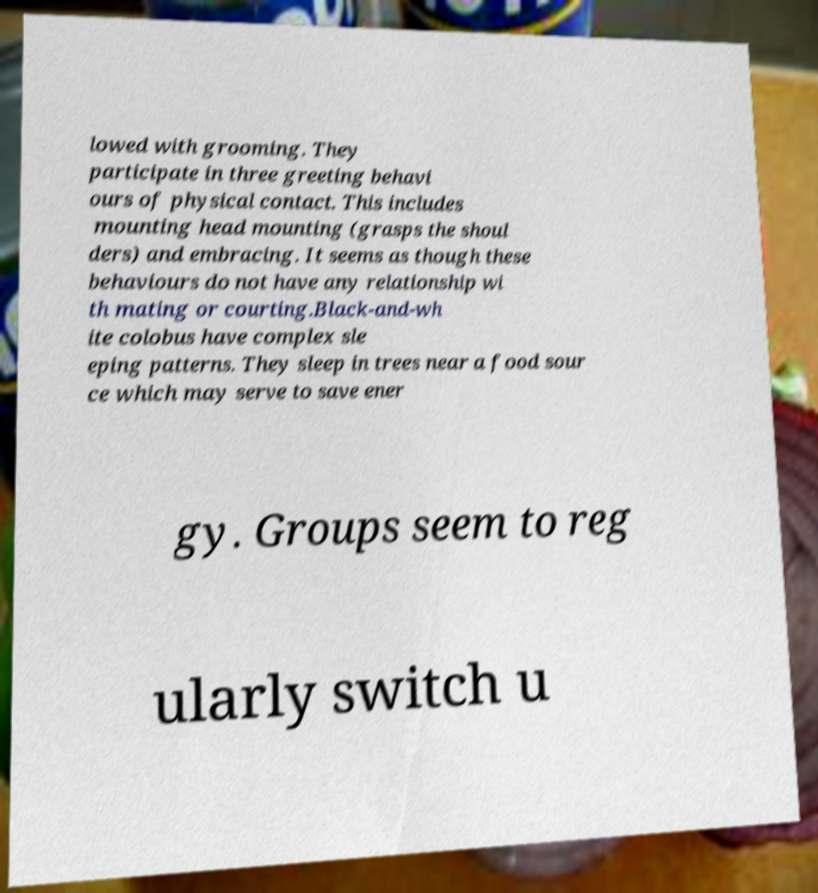I need the written content from this picture converted into text. Can you do that? lowed with grooming. They participate in three greeting behavi ours of physical contact. This includes mounting head mounting (grasps the shoul ders) and embracing. It seems as though these behaviours do not have any relationship wi th mating or courting.Black-and-wh ite colobus have complex sle eping patterns. They sleep in trees near a food sour ce which may serve to save ener gy. Groups seem to reg ularly switch u 